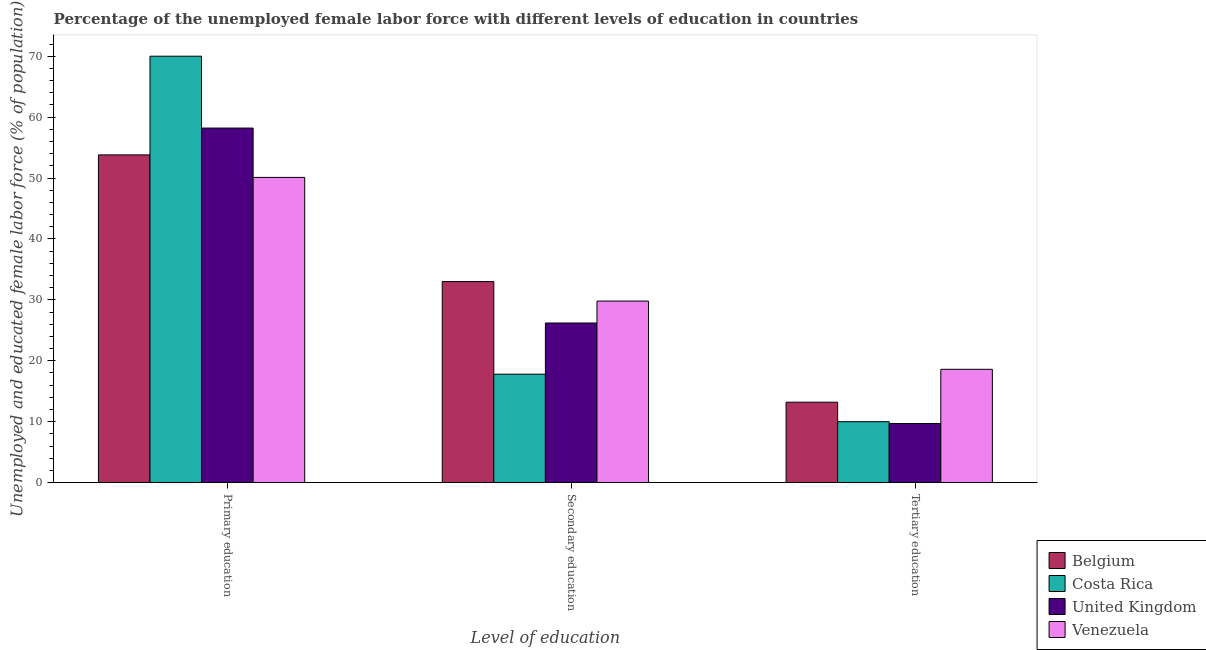How many different coloured bars are there?
Keep it short and to the point. 4. How many groups of bars are there?
Make the answer very short. 3. Are the number of bars on each tick of the X-axis equal?
Your answer should be compact. Yes. How many bars are there on the 2nd tick from the left?
Your response must be concise. 4. How many bars are there on the 2nd tick from the right?
Your answer should be compact. 4. What is the label of the 1st group of bars from the left?
Your answer should be compact. Primary education. What is the percentage of female labor force who received secondary education in Venezuela?
Offer a terse response. 29.8. Across all countries, what is the maximum percentage of female labor force who received tertiary education?
Ensure brevity in your answer.  18.6. Across all countries, what is the minimum percentage of female labor force who received secondary education?
Ensure brevity in your answer.  17.8. In which country was the percentage of female labor force who received primary education maximum?
Your answer should be compact. Costa Rica. What is the total percentage of female labor force who received tertiary education in the graph?
Make the answer very short. 51.5. What is the difference between the percentage of female labor force who received secondary education in Costa Rica and that in United Kingdom?
Make the answer very short. -8.4. What is the average percentage of female labor force who received tertiary education per country?
Your response must be concise. 12.87. What is the difference between the percentage of female labor force who received secondary education and percentage of female labor force who received tertiary education in Costa Rica?
Your answer should be very brief. 7.8. In how many countries, is the percentage of female labor force who received tertiary education greater than 18 %?
Keep it short and to the point. 1. What is the ratio of the percentage of female labor force who received tertiary education in United Kingdom to that in Costa Rica?
Ensure brevity in your answer.  0.97. Is the difference between the percentage of female labor force who received secondary education in Costa Rica and Venezuela greater than the difference between the percentage of female labor force who received tertiary education in Costa Rica and Venezuela?
Offer a terse response. No. What is the difference between the highest and the second highest percentage of female labor force who received tertiary education?
Offer a terse response. 5.4. What is the difference between the highest and the lowest percentage of female labor force who received primary education?
Give a very brief answer. 19.9. In how many countries, is the percentage of female labor force who received tertiary education greater than the average percentage of female labor force who received tertiary education taken over all countries?
Offer a terse response. 2. What does the 1st bar from the left in Secondary education represents?
Ensure brevity in your answer.  Belgium. What does the 1st bar from the right in Primary education represents?
Provide a succinct answer. Venezuela. Is it the case that in every country, the sum of the percentage of female labor force who received primary education and percentage of female labor force who received secondary education is greater than the percentage of female labor force who received tertiary education?
Your answer should be very brief. Yes. Are all the bars in the graph horizontal?
Provide a succinct answer. No. How many countries are there in the graph?
Provide a short and direct response. 4. Does the graph contain grids?
Ensure brevity in your answer.  No. How many legend labels are there?
Ensure brevity in your answer.  4. What is the title of the graph?
Make the answer very short. Percentage of the unemployed female labor force with different levels of education in countries. Does "Guyana" appear as one of the legend labels in the graph?
Your response must be concise. No. What is the label or title of the X-axis?
Give a very brief answer. Level of education. What is the label or title of the Y-axis?
Keep it short and to the point. Unemployed and educated female labor force (% of population). What is the Unemployed and educated female labor force (% of population) in Belgium in Primary education?
Offer a terse response. 53.8. What is the Unemployed and educated female labor force (% of population) in United Kingdom in Primary education?
Ensure brevity in your answer.  58.2. What is the Unemployed and educated female labor force (% of population) in Venezuela in Primary education?
Make the answer very short. 50.1. What is the Unemployed and educated female labor force (% of population) of Belgium in Secondary education?
Offer a terse response. 33. What is the Unemployed and educated female labor force (% of population) in Costa Rica in Secondary education?
Make the answer very short. 17.8. What is the Unemployed and educated female labor force (% of population) of United Kingdom in Secondary education?
Your answer should be very brief. 26.2. What is the Unemployed and educated female labor force (% of population) of Venezuela in Secondary education?
Offer a very short reply. 29.8. What is the Unemployed and educated female labor force (% of population) of Belgium in Tertiary education?
Your response must be concise. 13.2. What is the Unemployed and educated female labor force (% of population) of United Kingdom in Tertiary education?
Ensure brevity in your answer.  9.7. What is the Unemployed and educated female labor force (% of population) in Venezuela in Tertiary education?
Provide a succinct answer. 18.6. Across all Level of education, what is the maximum Unemployed and educated female labor force (% of population) in Belgium?
Offer a very short reply. 53.8. Across all Level of education, what is the maximum Unemployed and educated female labor force (% of population) of Costa Rica?
Offer a terse response. 70. Across all Level of education, what is the maximum Unemployed and educated female labor force (% of population) of United Kingdom?
Offer a very short reply. 58.2. Across all Level of education, what is the maximum Unemployed and educated female labor force (% of population) in Venezuela?
Offer a very short reply. 50.1. Across all Level of education, what is the minimum Unemployed and educated female labor force (% of population) in Belgium?
Your response must be concise. 13.2. Across all Level of education, what is the minimum Unemployed and educated female labor force (% of population) in United Kingdom?
Provide a succinct answer. 9.7. Across all Level of education, what is the minimum Unemployed and educated female labor force (% of population) of Venezuela?
Your answer should be compact. 18.6. What is the total Unemployed and educated female labor force (% of population) in Belgium in the graph?
Offer a terse response. 100. What is the total Unemployed and educated female labor force (% of population) of Costa Rica in the graph?
Ensure brevity in your answer.  97.8. What is the total Unemployed and educated female labor force (% of population) of United Kingdom in the graph?
Offer a terse response. 94.1. What is the total Unemployed and educated female labor force (% of population) of Venezuela in the graph?
Offer a very short reply. 98.5. What is the difference between the Unemployed and educated female labor force (% of population) of Belgium in Primary education and that in Secondary education?
Give a very brief answer. 20.8. What is the difference between the Unemployed and educated female labor force (% of population) in Costa Rica in Primary education and that in Secondary education?
Ensure brevity in your answer.  52.2. What is the difference between the Unemployed and educated female labor force (% of population) in Venezuela in Primary education and that in Secondary education?
Keep it short and to the point. 20.3. What is the difference between the Unemployed and educated female labor force (% of population) in Belgium in Primary education and that in Tertiary education?
Make the answer very short. 40.6. What is the difference between the Unemployed and educated female labor force (% of population) of Costa Rica in Primary education and that in Tertiary education?
Your answer should be compact. 60. What is the difference between the Unemployed and educated female labor force (% of population) in United Kingdom in Primary education and that in Tertiary education?
Make the answer very short. 48.5. What is the difference between the Unemployed and educated female labor force (% of population) in Venezuela in Primary education and that in Tertiary education?
Keep it short and to the point. 31.5. What is the difference between the Unemployed and educated female labor force (% of population) of Belgium in Secondary education and that in Tertiary education?
Provide a succinct answer. 19.8. What is the difference between the Unemployed and educated female labor force (% of population) of United Kingdom in Secondary education and that in Tertiary education?
Keep it short and to the point. 16.5. What is the difference between the Unemployed and educated female labor force (% of population) in Venezuela in Secondary education and that in Tertiary education?
Your answer should be compact. 11.2. What is the difference between the Unemployed and educated female labor force (% of population) of Belgium in Primary education and the Unemployed and educated female labor force (% of population) of United Kingdom in Secondary education?
Offer a terse response. 27.6. What is the difference between the Unemployed and educated female labor force (% of population) of Costa Rica in Primary education and the Unemployed and educated female labor force (% of population) of United Kingdom in Secondary education?
Provide a short and direct response. 43.8. What is the difference between the Unemployed and educated female labor force (% of population) in Costa Rica in Primary education and the Unemployed and educated female labor force (% of population) in Venezuela in Secondary education?
Provide a short and direct response. 40.2. What is the difference between the Unemployed and educated female labor force (% of population) of United Kingdom in Primary education and the Unemployed and educated female labor force (% of population) of Venezuela in Secondary education?
Keep it short and to the point. 28.4. What is the difference between the Unemployed and educated female labor force (% of population) of Belgium in Primary education and the Unemployed and educated female labor force (% of population) of Costa Rica in Tertiary education?
Offer a terse response. 43.8. What is the difference between the Unemployed and educated female labor force (% of population) of Belgium in Primary education and the Unemployed and educated female labor force (% of population) of United Kingdom in Tertiary education?
Provide a succinct answer. 44.1. What is the difference between the Unemployed and educated female labor force (% of population) of Belgium in Primary education and the Unemployed and educated female labor force (% of population) of Venezuela in Tertiary education?
Make the answer very short. 35.2. What is the difference between the Unemployed and educated female labor force (% of population) of Costa Rica in Primary education and the Unemployed and educated female labor force (% of population) of United Kingdom in Tertiary education?
Offer a terse response. 60.3. What is the difference between the Unemployed and educated female labor force (% of population) in Costa Rica in Primary education and the Unemployed and educated female labor force (% of population) in Venezuela in Tertiary education?
Offer a terse response. 51.4. What is the difference between the Unemployed and educated female labor force (% of population) in United Kingdom in Primary education and the Unemployed and educated female labor force (% of population) in Venezuela in Tertiary education?
Keep it short and to the point. 39.6. What is the difference between the Unemployed and educated female labor force (% of population) in Belgium in Secondary education and the Unemployed and educated female labor force (% of population) in United Kingdom in Tertiary education?
Offer a very short reply. 23.3. What is the difference between the Unemployed and educated female labor force (% of population) of United Kingdom in Secondary education and the Unemployed and educated female labor force (% of population) of Venezuela in Tertiary education?
Offer a very short reply. 7.6. What is the average Unemployed and educated female labor force (% of population) of Belgium per Level of education?
Your answer should be very brief. 33.33. What is the average Unemployed and educated female labor force (% of population) of Costa Rica per Level of education?
Your response must be concise. 32.6. What is the average Unemployed and educated female labor force (% of population) in United Kingdom per Level of education?
Give a very brief answer. 31.37. What is the average Unemployed and educated female labor force (% of population) of Venezuela per Level of education?
Offer a terse response. 32.83. What is the difference between the Unemployed and educated female labor force (% of population) in Belgium and Unemployed and educated female labor force (% of population) in Costa Rica in Primary education?
Give a very brief answer. -16.2. What is the difference between the Unemployed and educated female labor force (% of population) in Belgium and Unemployed and educated female labor force (% of population) in United Kingdom in Primary education?
Offer a very short reply. -4.4. What is the difference between the Unemployed and educated female labor force (% of population) in Belgium and Unemployed and educated female labor force (% of population) in Venezuela in Primary education?
Keep it short and to the point. 3.7. What is the difference between the Unemployed and educated female labor force (% of population) of Costa Rica and Unemployed and educated female labor force (% of population) of Venezuela in Primary education?
Make the answer very short. 19.9. What is the difference between the Unemployed and educated female labor force (% of population) of Belgium and Unemployed and educated female labor force (% of population) of Costa Rica in Secondary education?
Offer a very short reply. 15.2. What is the difference between the Unemployed and educated female labor force (% of population) of Belgium and Unemployed and educated female labor force (% of population) of United Kingdom in Secondary education?
Keep it short and to the point. 6.8. What is the difference between the Unemployed and educated female labor force (% of population) of Costa Rica and Unemployed and educated female labor force (% of population) of United Kingdom in Secondary education?
Your answer should be very brief. -8.4. What is the difference between the Unemployed and educated female labor force (% of population) of Costa Rica and Unemployed and educated female labor force (% of population) of Venezuela in Secondary education?
Your answer should be compact. -12. What is the difference between the Unemployed and educated female labor force (% of population) in United Kingdom and Unemployed and educated female labor force (% of population) in Venezuela in Secondary education?
Provide a succinct answer. -3.6. What is the difference between the Unemployed and educated female labor force (% of population) of Belgium and Unemployed and educated female labor force (% of population) of Costa Rica in Tertiary education?
Make the answer very short. 3.2. What is the difference between the Unemployed and educated female labor force (% of population) of Belgium and Unemployed and educated female labor force (% of population) of United Kingdom in Tertiary education?
Keep it short and to the point. 3.5. What is the difference between the Unemployed and educated female labor force (% of population) in Belgium and Unemployed and educated female labor force (% of population) in Venezuela in Tertiary education?
Your answer should be compact. -5.4. What is the difference between the Unemployed and educated female labor force (% of population) of Costa Rica and Unemployed and educated female labor force (% of population) of United Kingdom in Tertiary education?
Your answer should be very brief. 0.3. What is the difference between the Unemployed and educated female labor force (% of population) in Costa Rica and Unemployed and educated female labor force (% of population) in Venezuela in Tertiary education?
Keep it short and to the point. -8.6. What is the difference between the Unemployed and educated female labor force (% of population) of United Kingdom and Unemployed and educated female labor force (% of population) of Venezuela in Tertiary education?
Provide a succinct answer. -8.9. What is the ratio of the Unemployed and educated female labor force (% of population) of Belgium in Primary education to that in Secondary education?
Give a very brief answer. 1.63. What is the ratio of the Unemployed and educated female labor force (% of population) in Costa Rica in Primary education to that in Secondary education?
Your answer should be very brief. 3.93. What is the ratio of the Unemployed and educated female labor force (% of population) of United Kingdom in Primary education to that in Secondary education?
Offer a terse response. 2.22. What is the ratio of the Unemployed and educated female labor force (% of population) in Venezuela in Primary education to that in Secondary education?
Keep it short and to the point. 1.68. What is the ratio of the Unemployed and educated female labor force (% of population) of Belgium in Primary education to that in Tertiary education?
Provide a succinct answer. 4.08. What is the ratio of the Unemployed and educated female labor force (% of population) of Costa Rica in Primary education to that in Tertiary education?
Provide a succinct answer. 7. What is the ratio of the Unemployed and educated female labor force (% of population) of United Kingdom in Primary education to that in Tertiary education?
Provide a succinct answer. 6. What is the ratio of the Unemployed and educated female labor force (% of population) of Venezuela in Primary education to that in Tertiary education?
Make the answer very short. 2.69. What is the ratio of the Unemployed and educated female labor force (% of population) of Costa Rica in Secondary education to that in Tertiary education?
Make the answer very short. 1.78. What is the ratio of the Unemployed and educated female labor force (% of population) of United Kingdom in Secondary education to that in Tertiary education?
Provide a succinct answer. 2.7. What is the ratio of the Unemployed and educated female labor force (% of population) of Venezuela in Secondary education to that in Tertiary education?
Offer a very short reply. 1.6. What is the difference between the highest and the second highest Unemployed and educated female labor force (% of population) in Belgium?
Give a very brief answer. 20.8. What is the difference between the highest and the second highest Unemployed and educated female labor force (% of population) in Costa Rica?
Provide a succinct answer. 52.2. What is the difference between the highest and the second highest Unemployed and educated female labor force (% of population) in Venezuela?
Provide a short and direct response. 20.3. What is the difference between the highest and the lowest Unemployed and educated female labor force (% of population) in Belgium?
Offer a very short reply. 40.6. What is the difference between the highest and the lowest Unemployed and educated female labor force (% of population) of Costa Rica?
Give a very brief answer. 60. What is the difference between the highest and the lowest Unemployed and educated female labor force (% of population) of United Kingdom?
Your response must be concise. 48.5. What is the difference between the highest and the lowest Unemployed and educated female labor force (% of population) of Venezuela?
Keep it short and to the point. 31.5. 